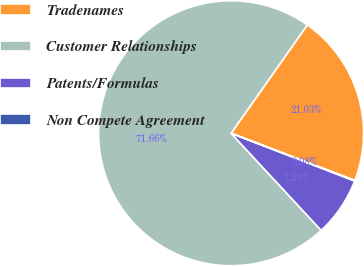Convert chart. <chart><loc_0><loc_0><loc_500><loc_500><pie_chart><fcel>Tradenames<fcel>Customer Relationships<fcel>Patents/Formulas<fcel>Non Compete Agreement<nl><fcel>21.03%<fcel>71.66%<fcel>7.23%<fcel>0.08%<nl></chart> 